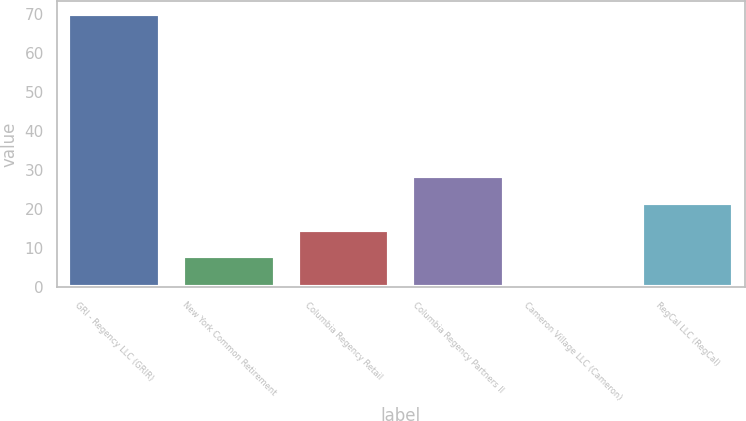<chart> <loc_0><loc_0><loc_500><loc_500><bar_chart><fcel>GRI - Regency LLC (GRIR)<fcel>New York Common Retirement<fcel>Columbia Regency Retail<fcel>Columbia Regency Partners II<fcel>Cameron Village LLC (Cameron)<fcel>RegCal LLC (RegCal)<nl><fcel>70<fcel>7.9<fcel>14.8<fcel>28.6<fcel>1<fcel>21.7<nl></chart> 